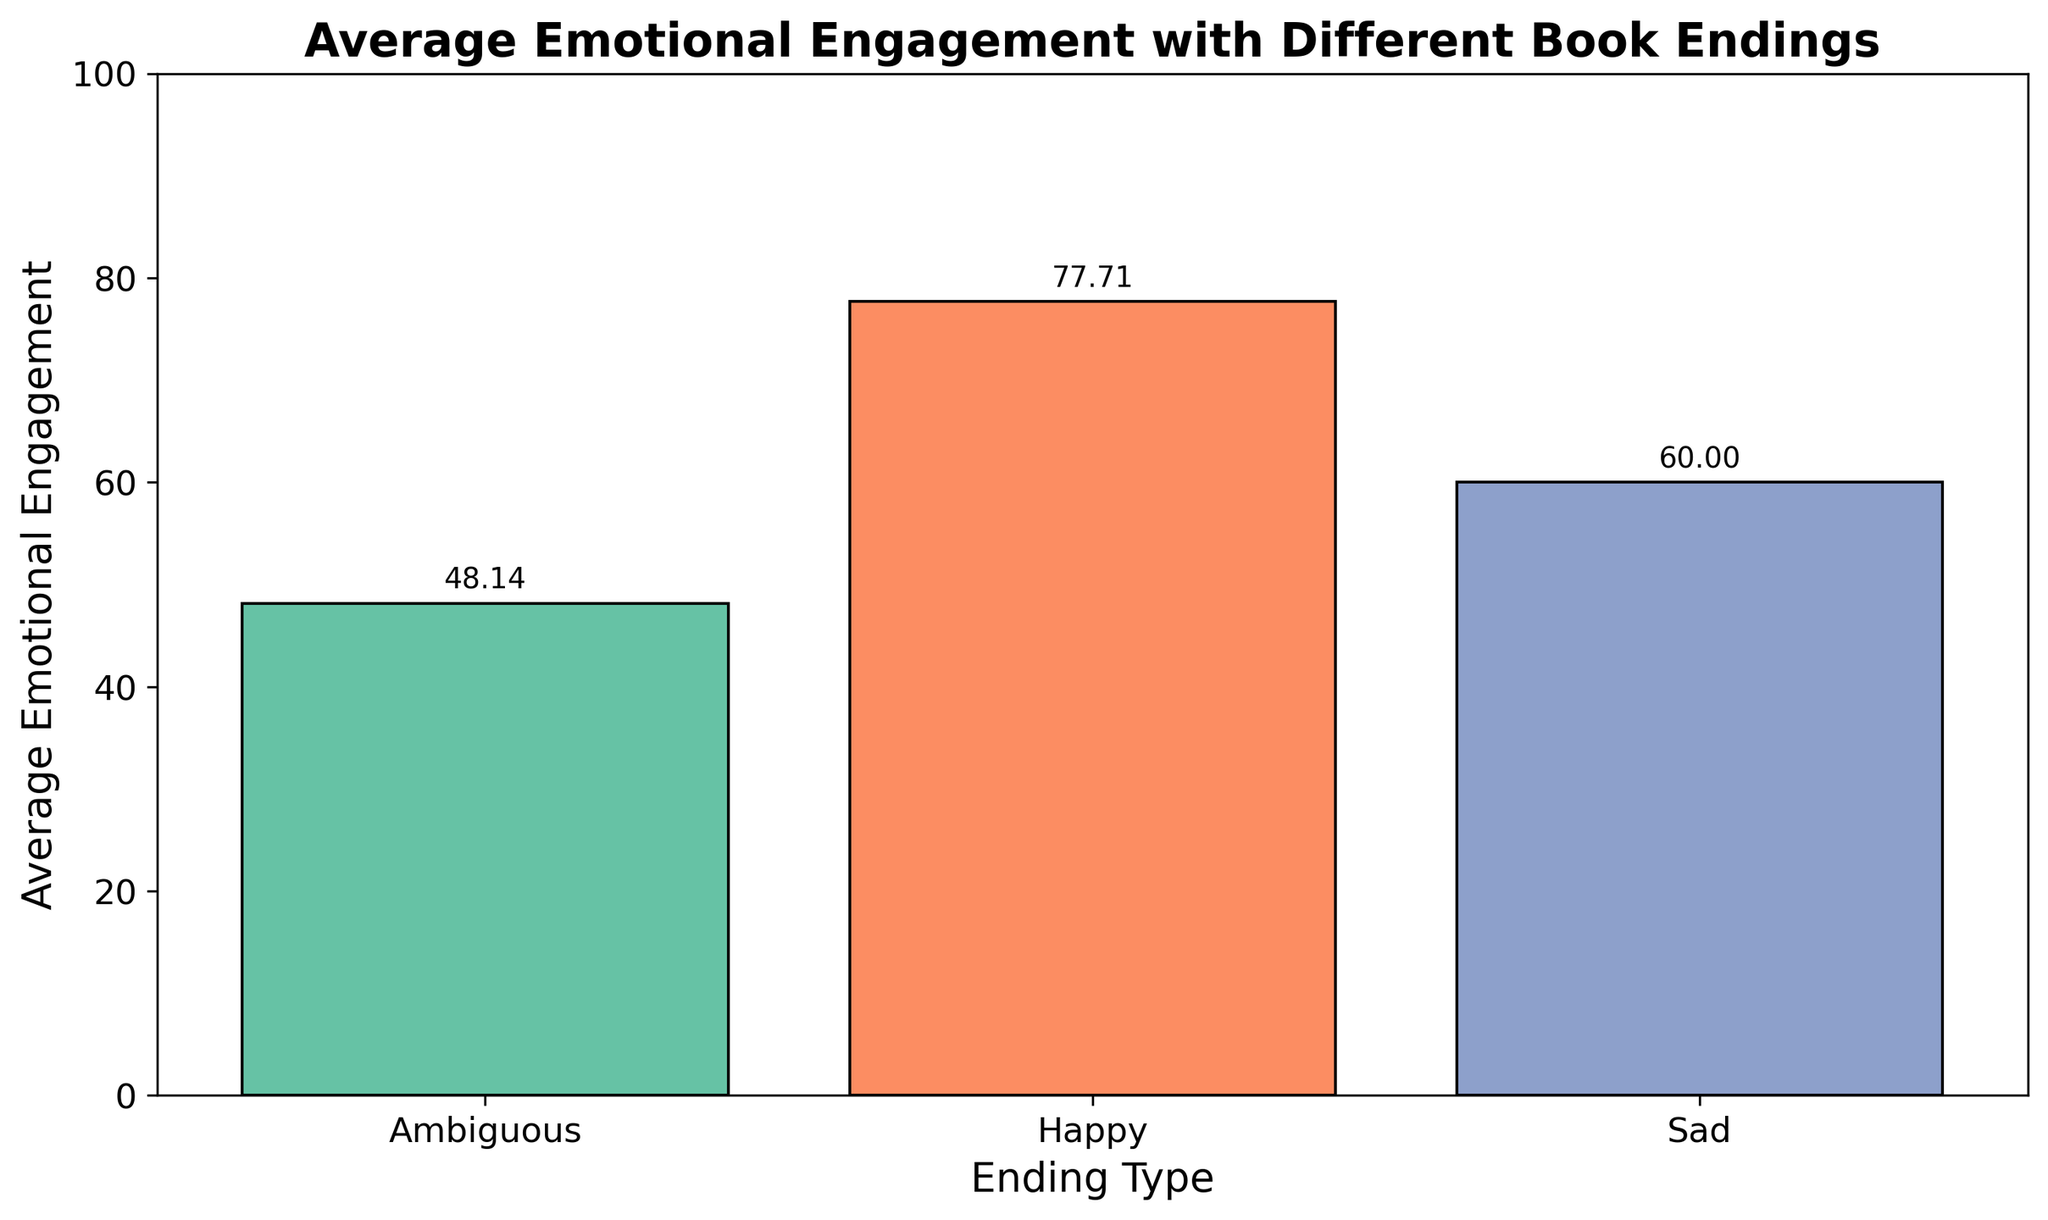Which ending type has the highest average emotional engagement? The bar for the "Happy" ending is the tallest, indicating the highest average emotional engagement.
Answer: Happy Which ending type has the lowest average emotional engagement? The bar for the "Ambiguous" ending is the shortest, indicating the lowest average emotional engagement.
Answer: Ambiguous What is the difference in average emotional engagement between the "Happy" and "Sad" endings? The average emotional engagement for "Happy" endings is around 77.57 and for "Sad" endings is around 60.00. The difference is 77.57 - 60.00 = 17.57.
Answer: 17.57 Is there a larger gap in emotional engagement between "Happy" and "Ambiguous" endings or between "Sad" and "Ambiguous" endings? The gap between "Happy" and "Ambiguous" is 77.57 - 48.43 = 29.14. The gap between "Sad" and "Ambiguous" is 60.00 - 48.43 = 11.57. The gap between "Happy" and "Ambiguous" is larger.
Answer: Happy and Ambiguous Which ending type has the second highest average emotional engagement? The second tallest bar corresponds to the "Sad" ending type, indicating the second highest average emotional engagement.
Answer: Sad Considering the bar heights, what is the approximate average emotional engagement for "Ambiguous" endings? The bar for "Ambiguous" endings indicates an average emotional engagement of approximately 48.43.
Answer: 48.43 By how much does the average emotional engagement for "Sad" endings exceed the average for "Ambiguous" endings? The average emotional engagement for "Sad" endings is around 60.00 and for "Ambiguous" is around 48.43. The difference is 60.00 - 48.43 = 11.57.
Answer: 11.57 What are the approximate average emotional engagement scores for "Happy," "Sad," and "Ambiguous" endings? The bar heights indicate approximate average emotional engagement scores of 77.57 for "Happy," 60.00 for "Sad," and 48.43 for "Ambiguous."
Answer: 77.57 (Happy), 60 (Sad), 48.43 (Ambiguous) 